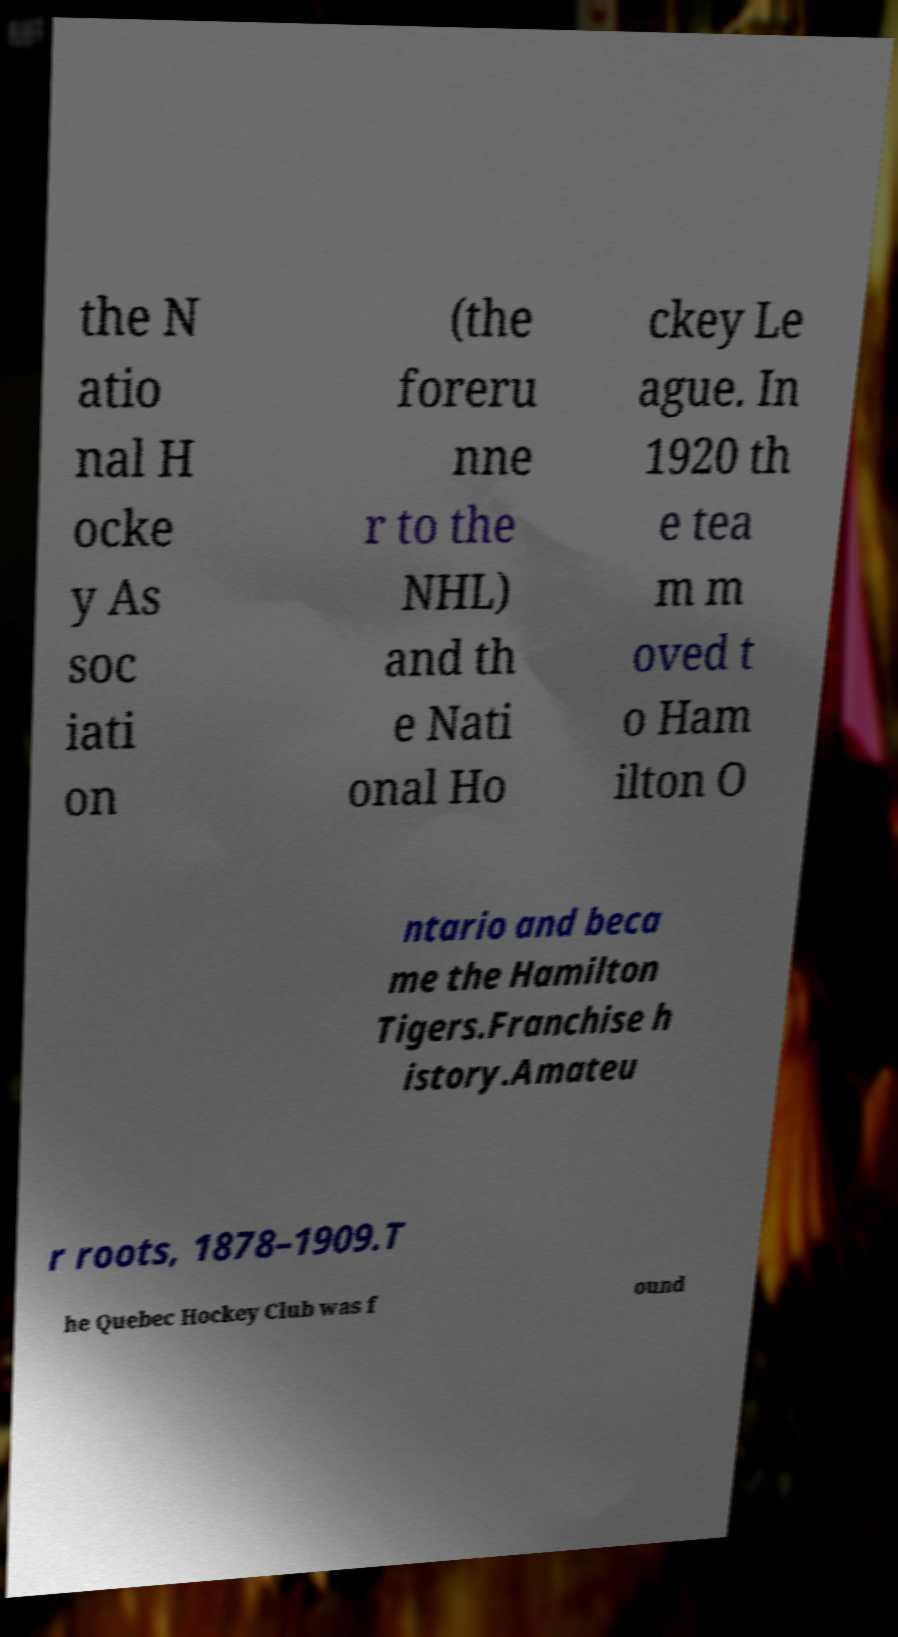For documentation purposes, I need the text within this image transcribed. Could you provide that? the N atio nal H ocke y As soc iati on (the foreru nne r to the NHL) and th e Nati onal Ho ckey Le ague. In 1920 th e tea m m oved t o Ham ilton O ntario and beca me the Hamilton Tigers.Franchise h istory.Amateu r roots, 1878–1909.T he Quebec Hockey Club was f ound 